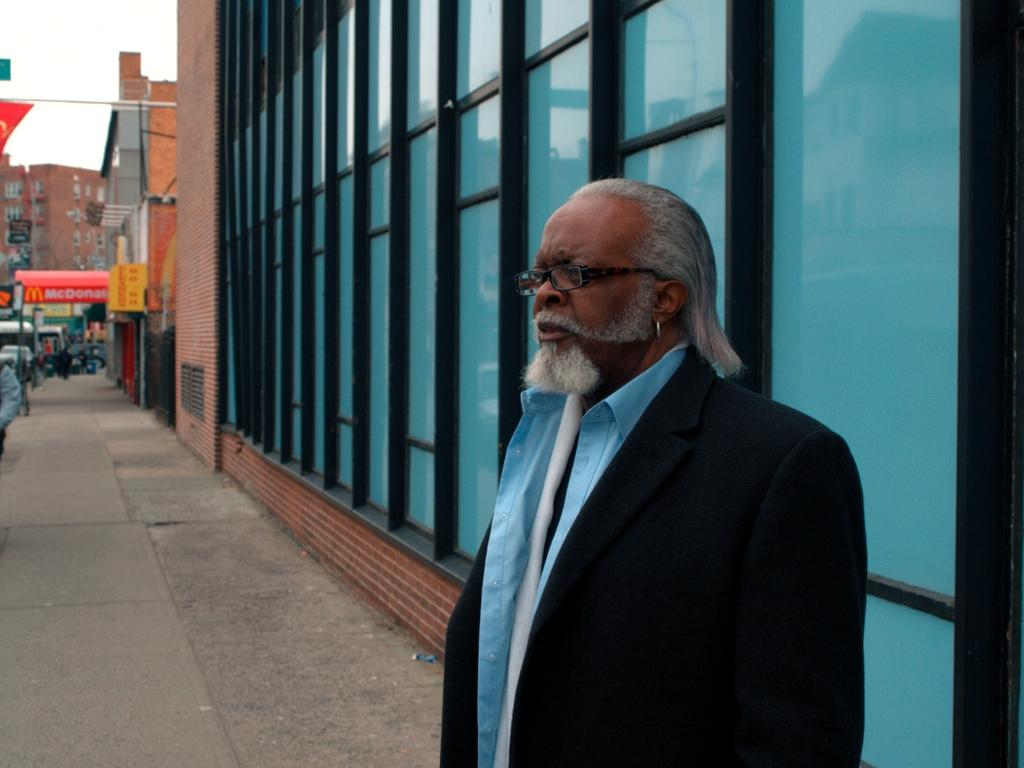What type of structures are visible in the image? There are buildings in the image. Can you describe the person at the bottom of the image? The person is at the bottom of the image. What is the person wearing in the image? The person is wearing clothes in the image. What type of shop can be seen in the image? There is no shop visible in the image; it only features buildings and a person. Does the person in the image feel any shame? There is no indication of the person's emotions in the image, so it cannot be determined if they feel shame. 